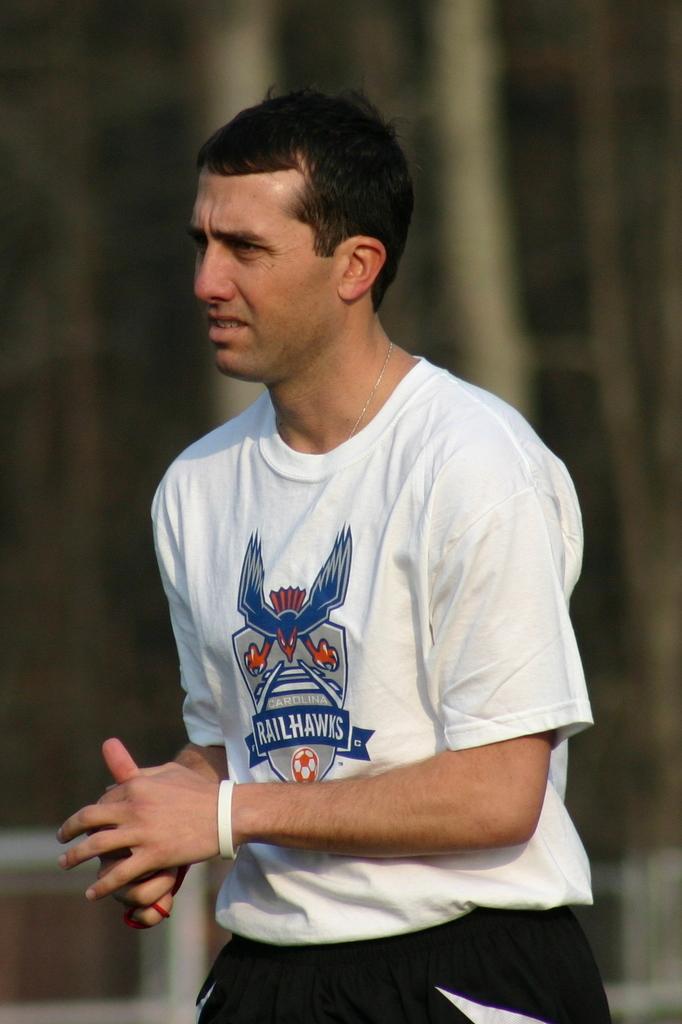What's the team name on the white t-shirt worn by the man/?
Provide a succinct answer. Railhawks. 